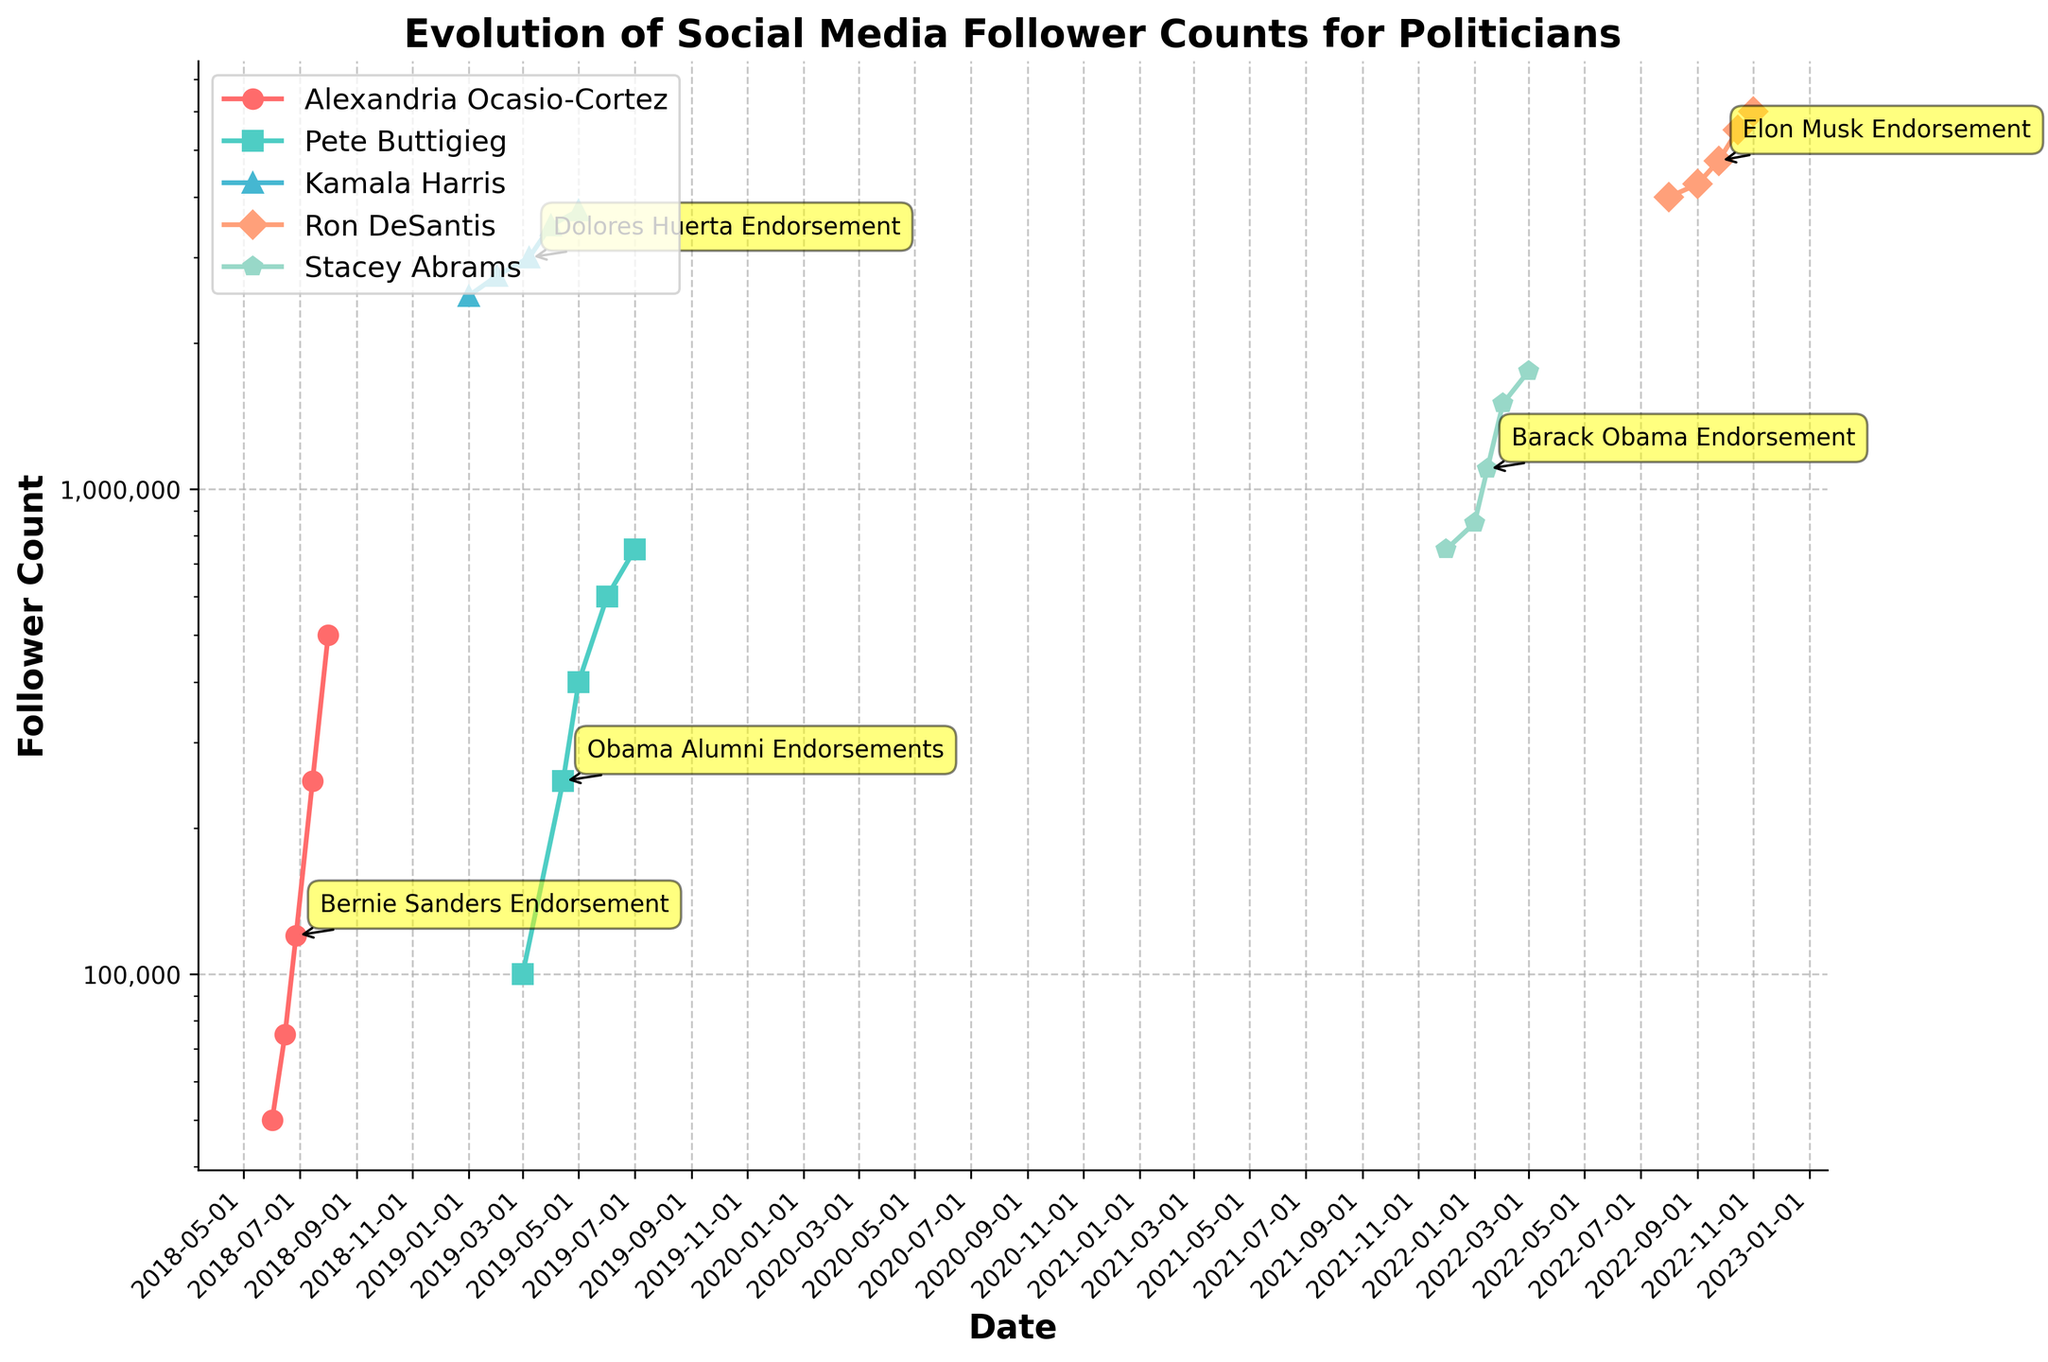What change in follower count did Alexandria Ocasio-Cortez experience immediately after Bernie Sanders' endorsement? Look at the follower counts for Alexandria Ocasio-Cortez just before and just after the endorsement on 2018-06-27. The count increased from 75,000 on 2018-06-15 to 120,000 on 2018-06-27. Subtracting the two values gives an increase of 45,000.
Answer: 45,000 Which politician had the highest follower count at any point before receiving an endorsement? Compare the follower counts before endorsements for all politicians. Kamala Harris had 2,750,000 followers on 2019-02-01, which is the highest among all politicians before any endorsement.
Answer: Kamala Harris How did Pete Buttigieg's follower count change from March 1, 2019, to July 1, 2019? View Pete Buttigieg's follower counts at both dates: 100,000 on 2019-03-01 and 750,000 on 2019-07-01. Subtract the initial count from the final count to get the change: 750,000 - 100,000 = 650,000.
Answer: 650,000 Between Kamala Harris and Ron DeSantis, who had a higher follower count growth one month after their endorsements, and by how much? Compare the growths one month after endorsements:
- Kamala Harris: From 3,000,000 on 2019-03-08 to 3,500,000 on 2019-04-01, a growth of 500,000.
- Ron DeSantis: From 4,750,000 on 2022-09-24 to 5,500,000 on 2022-10-15, a growth of 750,000.
Subtract Kamala Harris' growth from Ron DeSantis' growth: 750,000 - 500,000 = 250,000.
Answer: Ron DeSantis by 250,000 Which color represents Kamala Harris in the plot? Based on the description, each politician is assigned a unique color. Blue is typically associated with Kamala Harris among the given choices.
Answer: Blue What is the approximate follower count for Stacey Abrams just after receiving an endorsement from Barack Obama? Look at Stacey Abrams' follower count on 2022-01-15, just after the 2022-01-01 endorsement. The count is 1,100,000.
Answer: 1,100,000 Whose follower count trajectory is annotated with the event "Elon Musk Endorsement," and what are the associated date and follower count? Check the event annotations, and "Elon Musk Endorsement" is on 2022-09-24 for Ron DeSantis at a follower count of 4,750,000.
Answer: Ron DeSantis on 2022-09-24 with 4,750,000 